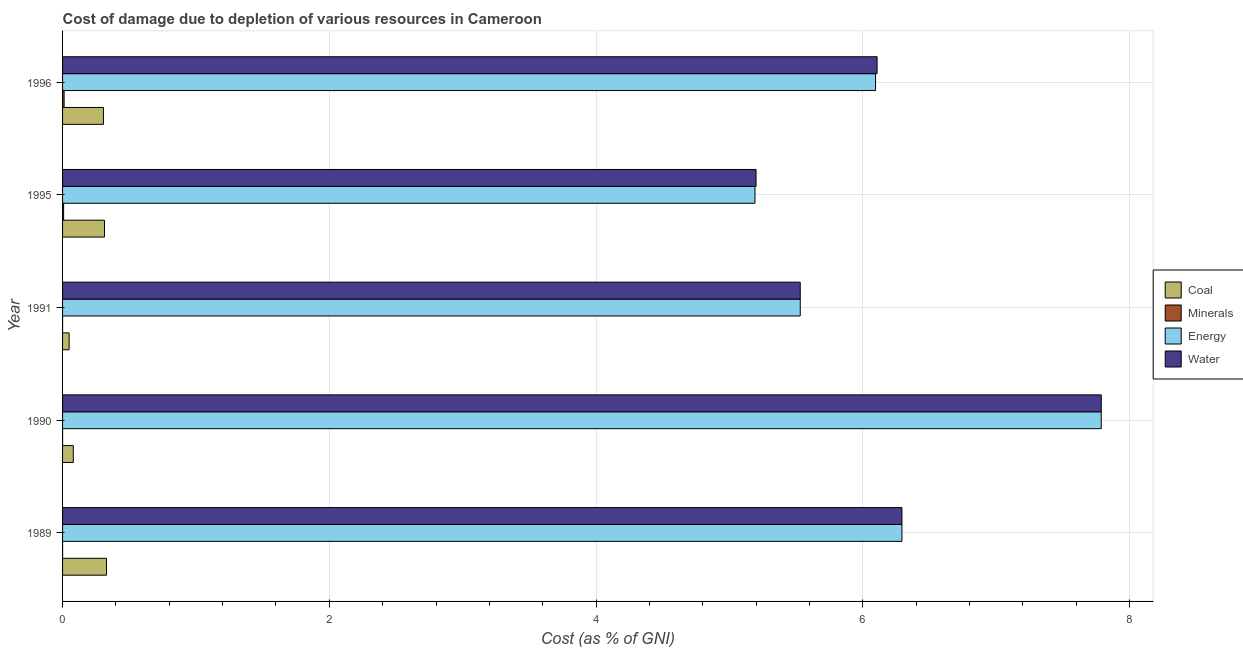How many bars are there on the 3rd tick from the bottom?
Offer a very short reply. 4. What is the cost of damage due to depletion of water in 1991?
Make the answer very short. 5.53. Across all years, what is the maximum cost of damage due to depletion of coal?
Make the answer very short. 0.33. Across all years, what is the minimum cost of damage due to depletion of energy?
Your answer should be very brief. 5.19. In which year was the cost of damage due to depletion of water maximum?
Your answer should be compact. 1990. In which year was the cost of damage due to depletion of coal minimum?
Your response must be concise. 1991. What is the total cost of damage due to depletion of coal in the graph?
Offer a very short reply. 1.08. What is the difference between the cost of damage due to depletion of water in 1989 and that in 1995?
Give a very brief answer. 1.09. What is the difference between the cost of damage due to depletion of energy in 1995 and the cost of damage due to depletion of minerals in 1991?
Provide a succinct answer. 5.19. What is the average cost of damage due to depletion of minerals per year?
Your response must be concise. 0. In the year 1996, what is the difference between the cost of damage due to depletion of energy and cost of damage due to depletion of minerals?
Provide a short and direct response. 6.08. In how many years, is the cost of damage due to depletion of energy greater than 2.4 %?
Keep it short and to the point. 5. What is the ratio of the cost of damage due to depletion of energy in 1989 to that in 1995?
Ensure brevity in your answer.  1.21. Is the difference between the cost of damage due to depletion of coal in 1995 and 1996 greater than the difference between the cost of damage due to depletion of energy in 1995 and 1996?
Provide a succinct answer. Yes. What is the difference between the highest and the second highest cost of damage due to depletion of water?
Offer a very short reply. 1.49. What is the difference between the highest and the lowest cost of damage due to depletion of coal?
Keep it short and to the point. 0.28. In how many years, is the cost of damage due to depletion of coal greater than the average cost of damage due to depletion of coal taken over all years?
Make the answer very short. 3. What does the 1st bar from the top in 1990 represents?
Offer a very short reply. Water. What does the 4th bar from the bottom in 1989 represents?
Provide a short and direct response. Water. Is it the case that in every year, the sum of the cost of damage due to depletion of coal and cost of damage due to depletion of minerals is greater than the cost of damage due to depletion of energy?
Your answer should be compact. No. How many bars are there?
Your answer should be very brief. 20. Are all the bars in the graph horizontal?
Keep it short and to the point. Yes. How many years are there in the graph?
Give a very brief answer. 5. What is the difference between two consecutive major ticks on the X-axis?
Make the answer very short. 2. Are the values on the major ticks of X-axis written in scientific E-notation?
Offer a terse response. No. Does the graph contain any zero values?
Your response must be concise. No. Does the graph contain grids?
Your answer should be very brief. Yes. How are the legend labels stacked?
Offer a terse response. Vertical. What is the title of the graph?
Provide a short and direct response. Cost of damage due to depletion of various resources in Cameroon . Does "Source data assessment" appear as one of the legend labels in the graph?
Make the answer very short. No. What is the label or title of the X-axis?
Offer a very short reply. Cost (as % of GNI). What is the Cost (as % of GNI) of Coal in 1989?
Provide a short and direct response. 0.33. What is the Cost (as % of GNI) in Minerals in 1989?
Offer a terse response. 8.21457348199539e-5. What is the Cost (as % of GNI) of Energy in 1989?
Ensure brevity in your answer.  6.29. What is the Cost (as % of GNI) in Water in 1989?
Give a very brief answer. 6.29. What is the Cost (as % of GNI) in Coal in 1990?
Your response must be concise. 0.08. What is the Cost (as % of GNI) of Minerals in 1990?
Ensure brevity in your answer.  7.378551595650559e-5. What is the Cost (as % of GNI) of Energy in 1990?
Provide a short and direct response. 7.79. What is the Cost (as % of GNI) in Water in 1990?
Give a very brief answer. 7.79. What is the Cost (as % of GNI) in Coal in 1991?
Provide a succinct answer. 0.05. What is the Cost (as % of GNI) in Minerals in 1991?
Ensure brevity in your answer.  4.942112114306161e-5. What is the Cost (as % of GNI) of Energy in 1991?
Your response must be concise. 5.53. What is the Cost (as % of GNI) in Water in 1991?
Provide a short and direct response. 5.53. What is the Cost (as % of GNI) of Coal in 1995?
Offer a very short reply. 0.31. What is the Cost (as % of GNI) in Minerals in 1995?
Offer a terse response. 0.01. What is the Cost (as % of GNI) in Energy in 1995?
Offer a terse response. 5.19. What is the Cost (as % of GNI) of Water in 1995?
Ensure brevity in your answer.  5.2. What is the Cost (as % of GNI) in Coal in 1996?
Keep it short and to the point. 0.31. What is the Cost (as % of GNI) in Minerals in 1996?
Offer a very short reply. 0.01. What is the Cost (as % of GNI) in Energy in 1996?
Provide a short and direct response. 6.1. What is the Cost (as % of GNI) of Water in 1996?
Your answer should be very brief. 6.11. Across all years, what is the maximum Cost (as % of GNI) in Coal?
Make the answer very short. 0.33. Across all years, what is the maximum Cost (as % of GNI) in Minerals?
Make the answer very short. 0.01. Across all years, what is the maximum Cost (as % of GNI) in Energy?
Make the answer very short. 7.79. Across all years, what is the maximum Cost (as % of GNI) of Water?
Give a very brief answer. 7.79. Across all years, what is the minimum Cost (as % of GNI) in Coal?
Ensure brevity in your answer.  0.05. Across all years, what is the minimum Cost (as % of GNI) of Minerals?
Keep it short and to the point. 4.942112114306161e-5. Across all years, what is the minimum Cost (as % of GNI) of Energy?
Provide a short and direct response. 5.19. Across all years, what is the minimum Cost (as % of GNI) of Water?
Provide a succinct answer. 5.2. What is the total Cost (as % of GNI) of Coal in the graph?
Ensure brevity in your answer.  1.08. What is the total Cost (as % of GNI) in Minerals in the graph?
Provide a succinct answer. 0.02. What is the total Cost (as % of GNI) of Energy in the graph?
Provide a succinct answer. 30.9. What is the total Cost (as % of GNI) of Water in the graph?
Keep it short and to the point. 30.92. What is the difference between the Cost (as % of GNI) in Coal in 1989 and that in 1990?
Give a very brief answer. 0.25. What is the difference between the Cost (as % of GNI) of Minerals in 1989 and that in 1990?
Your answer should be compact. 0. What is the difference between the Cost (as % of GNI) in Energy in 1989 and that in 1990?
Provide a succinct answer. -1.49. What is the difference between the Cost (as % of GNI) in Water in 1989 and that in 1990?
Your answer should be very brief. -1.49. What is the difference between the Cost (as % of GNI) in Coal in 1989 and that in 1991?
Keep it short and to the point. 0.28. What is the difference between the Cost (as % of GNI) in Energy in 1989 and that in 1991?
Make the answer very short. 0.76. What is the difference between the Cost (as % of GNI) in Water in 1989 and that in 1991?
Provide a succinct answer. 0.76. What is the difference between the Cost (as % of GNI) of Coal in 1989 and that in 1995?
Your response must be concise. 0.02. What is the difference between the Cost (as % of GNI) in Minerals in 1989 and that in 1995?
Your response must be concise. -0.01. What is the difference between the Cost (as % of GNI) in Energy in 1989 and that in 1995?
Ensure brevity in your answer.  1.1. What is the difference between the Cost (as % of GNI) of Water in 1989 and that in 1995?
Provide a succinct answer. 1.09. What is the difference between the Cost (as % of GNI) of Coal in 1989 and that in 1996?
Provide a short and direct response. 0.02. What is the difference between the Cost (as % of GNI) of Minerals in 1989 and that in 1996?
Keep it short and to the point. -0.01. What is the difference between the Cost (as % of GNI) in Energy in 1989 and that in 1996?
Give a very brief answer. 0.2. What is the difference between the Cost (as % of GNI) in Water in 1989 and that in 1996?
Your answer should be very brief. 0.19. What is the difference between the Cost (as % of GNI) of Coal in 1990 and that in 1991?
Make the answer very short. 0.03. What is the difference between the Cost (as % of GNI) in Minerals in 1990 and that in 1991?
Provide a succinct answer. 0. What is the difference between the Cost (as % of GNI) in Energy in 1990 and that in 1991?
Your answer should be compact. 2.26. What is the difference between the Cost (as % of GNI) of Water in 1990 and that in 1991?
Offer a very short reply. 2.26. What is the difference between the Cost (as % of GNI) of Coal in 1990 and that in 1995?
Your answer should be very brief. -0.23. What is the difference between the Cost (as % of GNI) of Minerals in 1990 and that in 1995?
Your response must be concise. -0.01. What is the difference between the Cost (as % of GNI) of Energy in 1990 and that in 1995?
Provide a succinct answer. 2.6. What is the difference between the Cost (as % of GNI) in Water in 1990 and that in 1995?
Your answer should be very brief. 2.59. What is the difference between the Cost (as % of GNI) of Coal in 1990 and that in 1996?
Your answer should be compact. -0.23. What is the difference between the Cost (as % of GNI) of Minerals in 1990 and that in 1996?
Ensure brevity in your answer.  -0.01. What is the difference between the Cost (as % of GNI) in Energy in 1990 and that in 1996?
Provide a succinct answer. 1.69. What is the difference between the Cost (as % of GNI) in Water in 1990 and that in 1996?
Ensure brevity in your answer.  1.68. What is the difference between the Cost (as % of GNI) in Coal in 1991 and that in 1995?
Keep it short and to the point. -0.27. What is the difference between the Cost (as % of GNI) of Minerals in 1991 and that in 1995?
Offer a very short reply. -0.01. What is the difference between the Cost (as % of GNI) of Energy in 1991 and that in 1995?
Make the answer very short. 0.34. What is the difference between the Cost (as % of GNI) in Water in 1991 and that in 1995?
Keep it short and to the point. 0.33. What is the difference between the Cost (as % of GNI) in Coal in 1991 and that in 1996?
Keep it short and to the point. -0.26. What is the difference between the Cost (as % of GNI) of Minerals in 1991 and that in 1996?
Provide a short and direct response. -0.01. What is the difference between the Cost (as % of GNI) in Energy in 1991 and that in 1996?
Offer a very short reply. -0.56. What is the difference between the Cost (as % of GNI) of Water in 1991 and that in 1996?
Provide a succinct answer. -0.58. What is the difference between the Cost (as % of GNI) in Coal in 1995 and that in 1996?
Your answer should be very brief. 0.01. What is the difference between the Cost (as % of GNI) in Minerals in 1995 and that in 1996?
Offer a very short reply. -0. What is the difference between the Cost (as % of GNI) of Energy in 1995 and that in 1996?
Offer a terse response. -0.9. What is the difference between the Cost (as % of GNI) of Water in 1995 and that in 1996?
Your answer should be very brief. -0.91. What is the difference between the Cost (as % of GNI) in Coal in 1989 and the Cost (as % of GNI) in Minerals in 1990?
Ensure brevity in your answer.  0.33. What is the difference between the Cost (as % of GNI) of Coal in 1989 and the Cost (as % of GNI) of Energy in 1990?
Your answer should be very brief. -7.46. What is the difference between the Cost (as % of GNI) in Coal in 1989 and the Cost (as % of GNI) in Water in 1990?
Your answer should be very brief. -7.46. What is the difference between the Cost (as % of GNI) of Minerals in 1989 and the Cost (as % of GNI) of Energy in 1990?
Offer a very short reply. -7.79. What is the difference between the Cost (as % of GNI) of Minerals in 1989 and the Cost (as % of GNI) of Water in 1990?
Offer a terse response. -7.79. What is the difference between the Cost (as % of GNI) in Energy in 1989 and the Cost (as % of GNI) in Water in 1990?
Give a very brief answer. -1.49. What is the difference between the Cost (as % of GNI) of Coal in 1989 and the Cost (as % of GNI) of Minerals in 1991?
Your answer should be very brief. 0.33. What is the difference between the Cost (as % of GNI) of Coal in 1989 and the Cost (as % of GNI) of Energy in 1991?
Your answer should be compact. -5.2. What is the difference between the Cost (as % of GNI) in Coal in 1989 and the Cost (as % of GNI) in Water in 1991?
Give a very brief answer. -5.2. What is the difference between the Cost (as % of GNI) of Minerals in 1989 and the Cost (as % of GNI) of Energy in 1991?
Offer a terse response. -5.53. What is the difference between the Cost (as % of GNI) of Minerals in 1989 and the Cost (as % of GNI) of Water in 1991?
Ensure brevity in your answer.  -5.53. What is the difference between the Cost (as % of GNI) of Energy in 1989 and the Cost (as % of GNI) of Water in 1991?
Provide a short and direct response. 0.76. What is the difference between the Cost (as % of GNI) in Coal in 1989 and the Cost (as % of GNI) in Minerals in 1995?
Make the answer very short. 0.32. What is the difference between the Cost (as % of GNI) of Coal in 1989 and the Cost (as % of GNI) of Energy in 1995?
Your response must be concise. -4.86. What is the difference between the Cost (as % of GNI) in Coal in 1989 and the Cost (as % of GNI) in Water in 1995?
Give a very brief answer. -4.87. What is the difference between the Cost (as % of GNI) of Minerals in 1989 and the Cost (as % of GNI) of Energy in 1995?
Provide a succinct answer. -5.19. What is the difference between the Cost (as % of GNI) in Minerals in 1989 and the Cost (as % of GNI) in Water in 1995?
Keep it short and to the point. -5.2. What is the difference between the Cost (as % of GNI) of Energy in 1989 and the Cost (as % of GNI) of Water in 1995?
Provide a short and direct response. 1.09. What is the difference between the Cost (as % of GNI) of Coal in 1989 and the Cost (as % of GNI) of Minerals in 1996?
Your response must be concise. 0.32. What is the difference between the Cost (as % of GNI) in Coal in 1989 and the Cost (as % of GNI) in Energy in 1996?
Offer a very short reply. -5.77. What is the difference between the Cost (as % of GNI) in Coal in 1989 and the Cost (as % of GNI) in Water in 1996?
Give a very brief answer. -5.78. What is the difference between the Cost (as % of GNI) in Minerals in 1989 and the Cost (as % of GNI) in Energy in 1996?
Offer a terse response. -6.09. What is the difference between the Cost (as % of GNI) in Minerals in 1989 and the Cost (as % of GNI) in Water in 1996?
Ensure brevity in your answer.  -6.11. What is the difference between the Cost (as % of GNI) of Energy in 1989 and the Cost (as % of GNI) of Water in 1996?
Offer a very short reply. 0.19. What is the difference between the Cost (as % of GNI) of Coal in 1990 and the Cost (as % of GNI) of Minerals in 1991?
Offer a terse response. 0.08. What is the difference between the Cost (as % of GNI) in Coal in 1990 and the Cost (as % of GNI) in Energy in 1991?
Offer a very short reply. -5.45. What is the difference between the Cost (as % of GNI) in Coal in 1990 and the Cost (as % of GNI) in Water in 1991?
Your answer should be compact. -5.45. What is the difference between the Cost (as % of GNI) of Minerals in 1990 and the Cost (as % of GNI) of Energy in 1991?
Ensure brevity in your answer.  -5.53. What is the difference between the Cost (as % of GNI) in Minerals in 1990 and the Cost (as % of GNI) in Water in 1991?
Give a very brief answer. -5.53. What is the difference between the Cost (as % of GNI) in Energy in 1990 and the Cost (as % of GNI) in Water in 1991?
Provide a short and direct response. 2.26. What is the difference between the Cost (as % of GNI) of Coal in 1990 and the Cost (as % of GNI) of Minerals in 1995?
Your response must be concise. 0.07. What is the difference between the Cost (as % of GNI) in Coal in 1990 and the Cost (as % of GNI) in Energy in 1995?
Keep it short and to the point. -5.11. What is the difference between the Cost (as % of GNI) in Coal in 1990 and the Cost (as % of GNI) in Water in 1995?
Give a very brief answer. -5.12. What is the difference between the Cost (as % of GNI) of Minerals in 1990 and the Cost (as % of GNI) of Energy in 1995?
Your answer should be compact. -5.19. What is the difference between the Cost (as % of GNI) in Minerals in 1990 and the Cost (as % of GNI) in Water in 1995?
Your response must be concise. -5.2. What is the difference between the Cost (as % of GNI) of Energy in 1990 and the Cost (as % of GNI) of Water in 1995?
Your answer should be compact. 2.59. What is the difference between the Cost (as % of GNI) in Coal in 1990 and the Cost (as % of GNI) in Minerals in 1996?
Your answer should be very brief. 0.07. What is the difference between the Cost (as % of GNI) in Coal in 1990 and the Cost (as % of GNI) in Energy in 1996?
Offer a terse response. -6.01. What is the difference between the Cost (as % of GNI) in Coal in 1990 and the Cost (as % of GNI) in Water in 1996?
Your answer should be very brief. -6.03. What is the difference between the Cost (as % of GNI) in Minerals in 1990 and the Cost (as % of GNI) in Energy in 1996?
Offer a very short reply. -6.1. What is the difference between the Cost (as % of GNI) of Minerals in 1990 and the Cost (as % of GNI) of Water in 1996?
Make the answer very short. -6.11. What is the difference between the Cost (as % of GNI) of Energy in 1990 and the Cost (as % of GNI) of Water in 1996?
Provide a short and direct response. 1.68. What is the difference between the Cost (as % of GNI) in Coal in 1991 and the Cost (as % of GNI) in Minerals in 1995?
Offer a terse response. 0.04. What is the difference between the Cost (as % of GNI) in Coal in 1991 and the Cost (as % of GNI) in Energy in 1995?
Offer a very short reply. -5.14. What is the difference between the Cost (as % of GNI) in Coal in 1991 and the Cost (as % of GNI) in Water in 1995?
Keep it short and to the point. -5.15. What is the difference between the Cost (as % of GNI) of Minerals in 1991 and the Cost (as % of GNI) of Energy in 1995?
Offer a very short reply. -5.19. What is the difference between the Cost (as % of GNI) of Minerals in 1991 and the Cost (as % of GNI) of Water in 1995?
Ensure brevity in your answer.  -5.2. What is the difference between the Cost (as % of GNI) of Energy in 1991 and the Cost (as % of GNI) of Water in 1995?
Offer a very short reply. 0.33. What is the difference between the Cost (as % of GNI) of Coal in 1991 and the Cost (as % of GNI) of Minerals in 1996?
Provide a succinct answer. 0.04. What is the difference between the Cost (as % of GNI) of Coal in 1991 and the Cost (as % of GNI) of Energy in 1996?
Provide a succinct answer. -6.05. What is the difference between the Cost (as % of GNI) in Coal in 1991 and the Cost (as % of GNI) in Water in 1996?
Offer a very short reply. -6.06. What is the difference between the Cost (as % of GNI) in Minerals in 1991 and the Cost (as % of GNI) in Energy in 1996?
Your answer should be very brief. -6.1. What is the difference between the Cost (as % of GNI) in Minerals in 1991 and the Cost (as % of GNI) in Water in 1996?
Offer a terse response. -6.11. What is the difference between the Cost (as % of GNI) of Energy in 1991 and the Cost (as % of GNI) of Water in 1996?
Offer a very short reply. -0.58. What is the difference between the Cost (as % of GNI) in Coal in 1995 and the Cost (as % of GNI) in Minerals in 1996?
Give a very brief answer. 0.3. What is the difference between the Cost (as % of GNI) of Coal in 1995 and the Cost (as % of GNI) of Energy in 1996?
Provide a short and direct response. -5.78. What is the difference between the Cost (as % of GNI) of Coal in 1995 and the Cost (as % of GNI) of Water in 1996?
Make the answer very short. -5.79. What is the difference between the Cost (as % of GNI) of Minerals in 1995 and the Cost (as % of GNI) of Energy in 1996?
Offer a very short reply. -6.09. What is the difference between the Cost (as % of GNI) in Minerals in 1995 and the Cost (as % of GNI) in Water in 1996?
Offer a terse response. -6.1. What is the difference between the Cost (as % of GNI) of Energy in 1995 and the Cost (as % of GNI) of Water in 1996?
Your answer should be very brief. -0.92. What is the average Cost (as % of GNI) of Coal per year?
Provide a succinct answer. 0.22. What is the average Cost (as % of GNI) in Minerals per year?
Your answer should be very brief. 0. What is the average Cost (as % of GNI) of Energy per year?
Your answer should be very brief. 6.18. What is the average Cost (as % of GNI) in Water per year?
Your answer should be very brief. 6.18. In the year 1989, what is the difference between the Cost (as % of GNI) in Coal and Cost (as % of GNI) in Minerals?
Your answer should be compact. 0.33. In the year 1989, what is the difference between the Cost (as % of GNI) of Coal and Cost (as % of GNI) of Energy?
Give a very brief answer. -5.96. In the year 1989, what is the difference between the Cost (as % of GNI) in Coal and Cost (as % of GNI) in Water?
Your response must be concise. -5.96. In the year 1989, what is the difference between the Cost (as % of GNI) in Minerals and Cost (as % of GNI) in Energy?
Ensure brevity in your answer.  -6.29. In the year 1989, what is the difference between the Cost (as % of GNI) of Minerals and Cost (as % of GNI) of Water?
Ensure brevity in your answer.  -6.29. In the year 1989, what is the difference between the Cost (as % of GNI) in Energy and Cost (as % of GNI) in Water?
Ensure brevity in your answer.  -0. In the year 1990, what is the difference between the Cost (as % of GNI) of Coal and Cost (as % of GNI) of Minerals?
Provide a short and direct response. 0.08. In the year 1990, what is the difference between the Cost (as % of GNI) in Coal and Cost (as % of GNI) in Energy?
Provide a short and direct response. -7.71. In the year 1990, what is the difference between the Cost (as % of GNI) of Coal and Cost (as % of GNI) of Water?
Your answer should be compact. -7.71. In the year 1990, what is the difference between the Cost (as % of GNI) of Minerals and Cost (as % of GNI) of Energy?
Make the answer very short. -7.79. In the year 1990, what is the difference between the Cost (as % of GNI) of Minerals and Cost (as % of GNI) of Water?
Offer a very short reply. -7.79. In the year 1990, what is the difference between the Cost (as % of GNI) in Energy and Cost (as % of GNI) in Water?
Make the answer very short. -0. In the year 1991, what is the difference between the Cost (as % of GNI) of Coal and Cost (as % of GNI) of Minerals?
Your answer should be compact. 0.05. In the year 1991, what is the difference between the Cost (as % of GNI) in Coal and Cost (as % of GNI) in Energy?
Keep it short and to the point. -5.48. In the year 1991, what is the difference between the Cost (as % of GNI) in Coal and Cost (as % of GNI) in Water?
Your answer should be compact. -5.48. In the year 1991, what is the difference between the Cost (as % of GNI) of Minerals and Cost (as % of GNI) of Energy?
Provide a succinct answer. -5.53. In the year 1991, what is the difference between the Cost (as % of GNI) in Minerals and Cost (as % of GNI) in Water?
Offer a very short reply. -5.53. In the year 1991, what is the difference between the Cost (as % of GNI) of Energy and Cost (as % of GNI) of Water?
Offer a very short reply. -0. In the year 1995, what is the difference between the Cost (as % of GNI) in Coal and Cost (as % of GNI) in Minerals?
Provide a succinct answer. 0.31. In the year 1995, what is the difference between the Cost (as % of GNI) of Coal and Cost (as % of GNI) of Energy?
Provide a short and direct response. -4.88. In the year 1995, what is the difference between the Cost (as % of GNI) of Coal and Cost (as % of GNI) of Water?
Keep it short and to the point. -4.88. In the year 1995, what is the difference between the Cost (as % of GNI) of Minerals and Cost (as % of GNI) of Energy?
Ensure brevity in your answer.  -5.18. In the year 1995, what is the difference between the Cost (as % of GNI) in Minerals and Cost (as % of GNI) in Water?
Provide a short and direct response. -5.19. In the year 1995, what is the difference between the Cost (as % of GNI) of Energy and Cost (as % of GNI) of Water?
Provide a succinct answer. -0.01. In the year 1996, what is the difference between the Cost (as % of GNI) of Coal and Cost (as % of GNI) of Minerals?
Offer a terse response. 0.29. In the year 1996, what is the difference between the Cost (as % of GNI) in Coal and Cost (as % of GNI) in Energy?
Your response must be concise. -5.79. In the year 1996, what is the difference between the Cost (as % of GNI) of Coal and Cost (as % of GNI) of Water?
Offer a very short reply. -5.8. In the year 1996, what is the difference between the Cost (as % of GNI) of Minerals and Cost (as % of GNI) of Energy?
Ensure brevity in your answer.  -6.08. In the year 1996, what is the difference between the Cost (as % of GNI) of Minerals and Cost (as % of GNI) of Water?
Your response must be concise. -6.1. In the year 1996, what is the difference between the Cost (as % of GNI) of Energy and Cost (as % of GNI) of Water?
Ensure brevity in your answer.  -0.01. What is the ratio of the Cost (as % of GNI) in Coal in 1989 to that in 1990?
Provide a short and direct response. 4.09. What is the ratio of the Cost (as % of GNI) of Minerals in 1989 to that in 1990?
Offer a very short reply. 1.11. What is the ratio of the Cost (as % of GNI) of Energy in 1989 to that in 1990?
Give a very brief answer. 0.81. What is the ratio of the Cost (as % of GNI) in Water in 1989 to that in 1990?
Your answer should be compact. 0.81. What is the ratio of the Cost (as % of GNI) in Coal in 1989 to that in 1991?
Offer a very short reply. 6.69. What is the ratio of the Cost (as % of GNI) of Minerals in 1989 to that in 1991?
Your response must be concise. 1.66. What is the ratio of the Cost (as % of GNI) in Energy in 1989 to that in 1991?
Make the answer very short. 1.14. What is the ratio of the Cost (as % of GNI) of Water in 1989 to that in 1991?
Offer a terse response. 1.14. What is the ratio of the Cost (as % of GNI) in Coal in 1989 to that in 1995?
Your answer should be very brief. 1.05. What is the ratio of the Cost (as % of GNI) of Minerals in 1989 to that in 1995?
Your answer should be very brief. 0.01. What is the ratio of the Cost (as % of GNI) of Energy in 1989 to that in 1995?
Give a very brief answer. 1.21. What is the ratio of the Cost (as % of GNI) of Water in 1989 to that in 1995?
Your answer should be very brief. 1.21. What is the ratio of the Cost (as % of GNI) of Coal in 1989 to that in 1996?
Your answer should be very brief. 1.07. What is the ratio of the Cost (as % of GNI) in Minerals in 1989 to that in 1996?
Provide a short and direct response. 0.01. What is the ratio of the Cost (as % of GNI) of Energy in 1989 to that in 1996?
Offer a very short reply. 1.03. What is the ratio of the Cost (as % of GNI) of Water in 1989 to that in 1996?
Ensure brevity in your answer.  1.03. What is the ratio of the Cost (as % of GNI) of Coal in 1990 to that in 1991?
Offer a terse response. 1.63. What is the ratio of the Cost (as % of GNI) of Minerals in 1990 to that in 1991?
Offer a terse response. 1.49. What is the ratio of the Cost (as % of GNI) of Energy in 1990 to that in 1991?
Make the answer very short. 1.41. What is the ratio of the Cost (as % of GNI) of Water in 1990 to that in 1991?
Give a very brief answer. 1.41. What is the ratio of the Cost (as % of GNI) of Coal in 1990 to that in 1995?
Your answer should be very brief. 0.26. What is the ratio of the Cost (as % of GNI) of Minerals in 1990 to that in 1995?
Your answer should be very brief. 0.01. What is the ratio of the Cost (as % of GNI) in Energy in 1990 to that in 1995?
Give a very brief answer. 1.5. What is the ratio of the Cost (as % of GNI) of Water in 1990 to that in 1995?
Offer a very short reply. 1.5. What is the ratio of the Cost (as % of GNI) of Coal in 1990 to that in 1996?
Give a very brief answer. 0.26. What is the ratio of the Cost (as % of GNI) in Minerals in 1990 to that in 1996?
Offer a very short reply. 0.01. What is the ratio of the Cost (as % of GNI) of Energy in 1990 to that in 1996?
Offer a very short reply. 1.28. What is the ratio of the Cost (as % of GNI) in Water in 1990 to that in 1996?
Your answer should be compact. 1.28. What is the ratio of the Cost (as % of GNI) in Coal in 1991 to that in 1995?
Ensure brevity in your answer.  0.16. What is the ratio of the Cost (as % of GNI) of Minerals in 1991 to that in 1995?
Your response must be concise. 0.01. What is the ratio of the Cost (as % of GNI) of Energy in 1991 to that in 1995?
Offer a terse response. 1.07. What is the ratio of the Cost (as % of GNI) in Water in 1991 to that in 1995?
Provide a short and direct response. 1.06. What is the ratio of the Cost (as % of GNI) in Coal in 1991 to that in 1996?
Provide a short and direct response. 0.16. What is the ratio of the Cost (as % of GNI) in Minerals in 1991 to that in 1996?
Ensure brevity in your answer.  0. What is the ratio of the Cost (as % of GNI) of Energy in 1991 to that in 1996?
Your answer should be very brief. 0.91. What is the ratio of the Cost (as % of GNI) in Water in 1991 to that in 1996?
Offer a very short reply. 0.91. What is the ratio of the Cost (as % of GNI) of Coal in 1995 to that in 1996?
Make the answer very short. 1.03. What is the ratio of the Cost (as % of GNI) of Minerals in 1995 to that in 1996?
Ensure brevity in your answer.  0.69. What is the ratio of the Cost (as % of GNI) in Energy in 1995 to that in 1996?
Provide a short and direct response. 0.85. What is the ratio of the Cost (as % of GNI) in Water in 1995 to that in 1996?
Make the answer very short. 0.85. What is the difference between the highest and the second highest Cost (as % of GNI) of Coal?
Offer a terse response. 0.02. What is the difference between the highest and the second highest Cost (as % of GNI) in Minerals?
Give a very brief answer. 0. What is the difference between the highest and the second highest Cost (as % of GNI) of Energy?
Provide a short and direct response. 1.49. What is the difference between the highest and the second highest Cost (as % of GNI) of Water?
Offer a terse response. 1.49. What is the difference between the highest and the lowest Cost (as % of GNI) in Coal?
Give a very brief answer. 0.28. What is the difference between the highest and the lowest Cost (as % of GNI) of Minerals?
Keep it short and to the point. 0.01. What is the difference between the highest and the lowest Cost (as % of GNI) of Energy?
Provide a short and direct response. 2.6. What is the difference between the highest and the lowest Cost (as % of GNI) in Water?
Your answer should be compact. 2.59. 